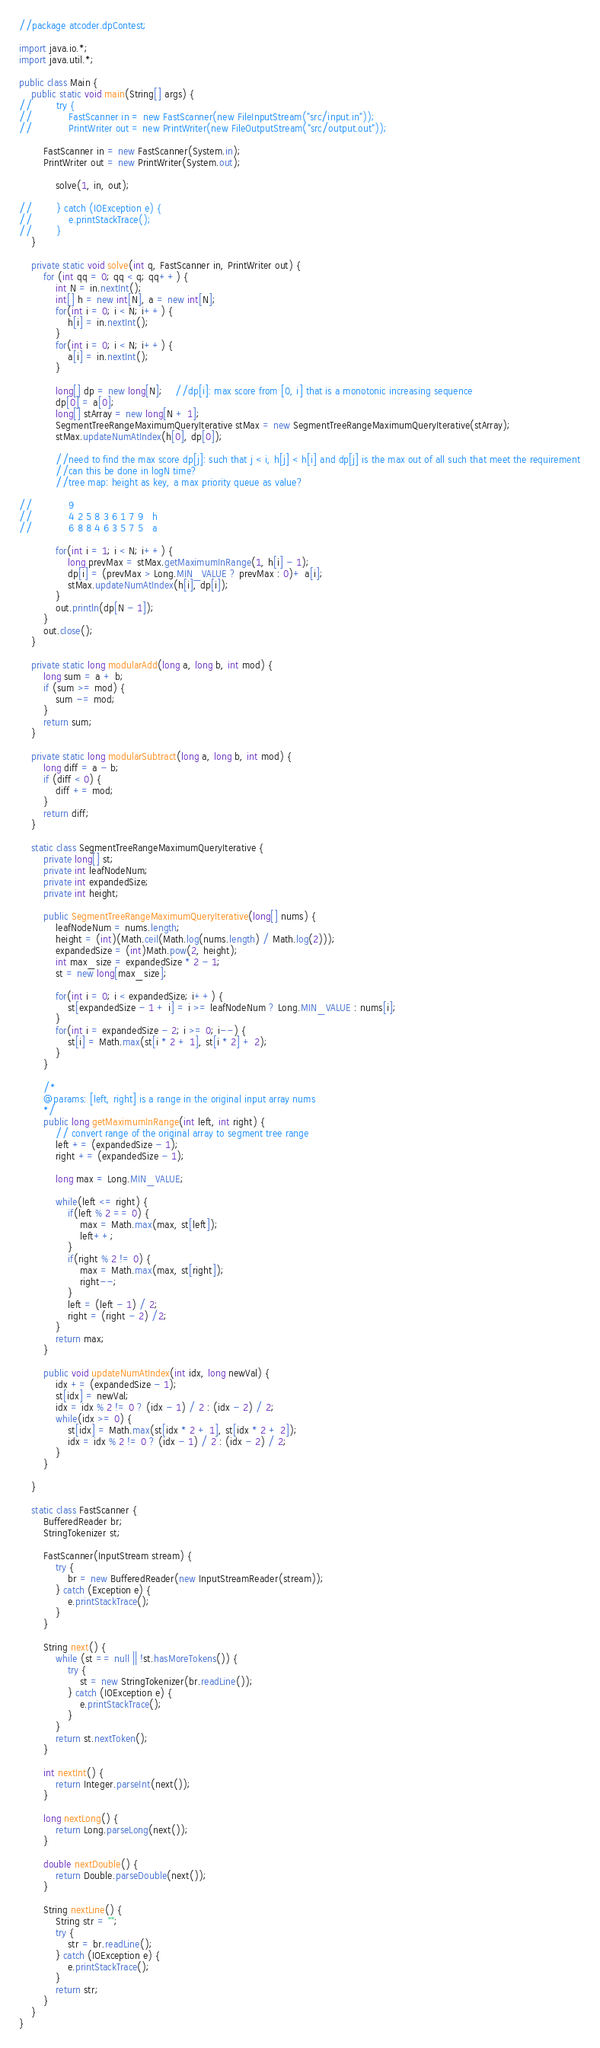Convert code to text. <code><loc_0><loc_0><loc_500><loc_500><_Java_>//package atcoder.dpContest;

import java.io.*;
import java.util.*;

public class Main {
    public static void main(String[] args) {
//        try {
//            FastScanner in = new FastScanner(new FileInputStream("src/input.in"));
//            PrintWriter out = new PrintWriter(new FileOutputStream("src/output.out"));

        FastScanner in = new FastScanner(System.in);
        PrintWriter out = new PrintWriter(System.out);

            solve(1, in, out);

//        } catch (IOException e) {
//            e.printStackTrace();
//        }
    }

    private static void solve(int q, FastScanner in, PrintWriter out) {
        for (int qq = 0; qq < q; qq++) {
            int N = in.nextInt();
            int[] h = new int[N], a = new int[N];
            for(int i = 0; i < N; i++) {
                h[i] = in.nextInt();
            }
            for(int i = 0; i < N; i++) {
                a[i] = in.nextInt();
            }

            long[] dp = new long[N];    //dp[i]: max score from [0, i] that is a monotonic increasing sequence
            dp[0] = a[0];
            long[] stArray = new long[N + 1];
            SegmentTreeRangeMaximumQueryIterative stMax = new SegmentTreeRangeMaximumQueryIterative(stArray);
            stMax.updateNumAtIndex(h[0], dp[0]);

            //need to find the max score dp[j]: such that j < i, h[j] < h[i] and dp[j] is the max out of all such that meet the requirement
            //can this be done in logN time?
            //tree map: height as key, a max priority queue as value?

//            9
//            4 2 5 8 3 6 1 7 9   h
//            6 8 8 4 6 3 5 7 5   a

            for(int i = 1; i < N; i++) {
                long prevMax = stMax.getMaximumInRange(1, h[i] - 1);
                dp[i] = (prevMax > Long.MIN_VALUE ? prevMax : 0)+ a[i];
                stMax.updateNumAtIndex(h[i], dp[i]);
            }
            out.println(dp[N - 1]);
        }
        out.close();
    }

    private static long modularAdd(long a, long b, int mod) {
        long sum = a + b;
        if (sum >= mod) {
            sum -= mod;
        }
        return sum;
    }

    private static long modularSubtract(long a, long b, int mod) {
        long diff = a - b;
        if (diff < 0) {
            diff += mod;
        }
        return diff;
    }

    static class SegmentTreeRangeMaximumQueryIterative {
        private long[] st;
        private int leafNodeNum;
        private int expandedSize;
        private int height;

        public SegmentTreeRangeMaximumQueryIterative(long[] nums) {
            leafNodeNum = nums.length;
            height = (int)(Math.ceil(Math.log(nums.length) / Math.log(2)));
            expandedSize = (int)Math.pow(2, height);
            int max_size = expandedSize * 2 - 1;
            st = new long[max_size];

            for(int i = 0; i < expandedSize; i++) {
                st[expandedSize - 1 + i] = i >= leafNodeNum ? Long.MIN_VALUE : nums[i];
            }
            for(int i = expandedSize - 2; i >= 0; i--) {
                st[i] = Math.max(st[i * 2 + 1], st[i * 2] + 2);
            }
        }

        /*
        @params: [left, right] is a range in the original input array nums
        */
        public long getMaximumInRange(int left, int right) {
            // convert range of the original array to segment tree range
            left += (expandedSize - 1);
            right += (expandedSize - 1);

            long max = Long.MIN_VALUE;

            while(left <= right) {
                if(left % 2 == 0) {
                    max = Math.max(max, st[left]);
                    left++;
                }
                if(right % 2 != 0) {
                    max = Math.max(max, st[right]);
                    right--;
                }
                left = (left - 1) / 2;
                right = (right - 2) /2;
            }
            return max;
        }

        public void updateNumAtIndex(int idx, long newVal) {
            idx += (expandedSize - 1);
            st[idx] = newVal;
            idx = idx % 2 != 0 ? (idx - 1) / 2 : (idx - 2) / 2;
            while(idx >= 0) {
                st[idx] = Math.max(st[idx * 2 + 1], st[idx * 2 + 2]);
                idx = idx % 2 != 0 ? (idx - 1) / 2 : (idx - 2) / 2;
            }
        }

    }

    static class FastScanner {
        BufferedReader br;
        StringTokenizer st;

        FastScanner(InputStream stream) {
            try {
                br = new BufferedReader(new InputStreamReader(stream));
            } catch (Exception e) {
                e.printStackTrace();
            }
        }

        String next() {
            while (st == null || !st.hasMoreTokens()) {
                try {
                    st = new StringTokenizer(br.readLine());
                } catch (IOException e) {
                    e.printStackTrace();
                }
            }
            return st.nextToken();
        }

        int nextInt() {
            return Integer.parseInt(next());
        }

        long nextLong() {
            return Long.parseLong(next());
        }

        double nextDouble() {
            return Double.parseDouble(next());
        }

        String nextLine() {
            String str = "";
            try {
                str = br.readLine();
            } catch (IOException e) {
                e.printStackTrace();
            }
            return str;
        }
    }
}


</code> 